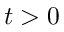<formula> <loc_0><loc_0><loc_500><loc_500>t > 0</formula> 